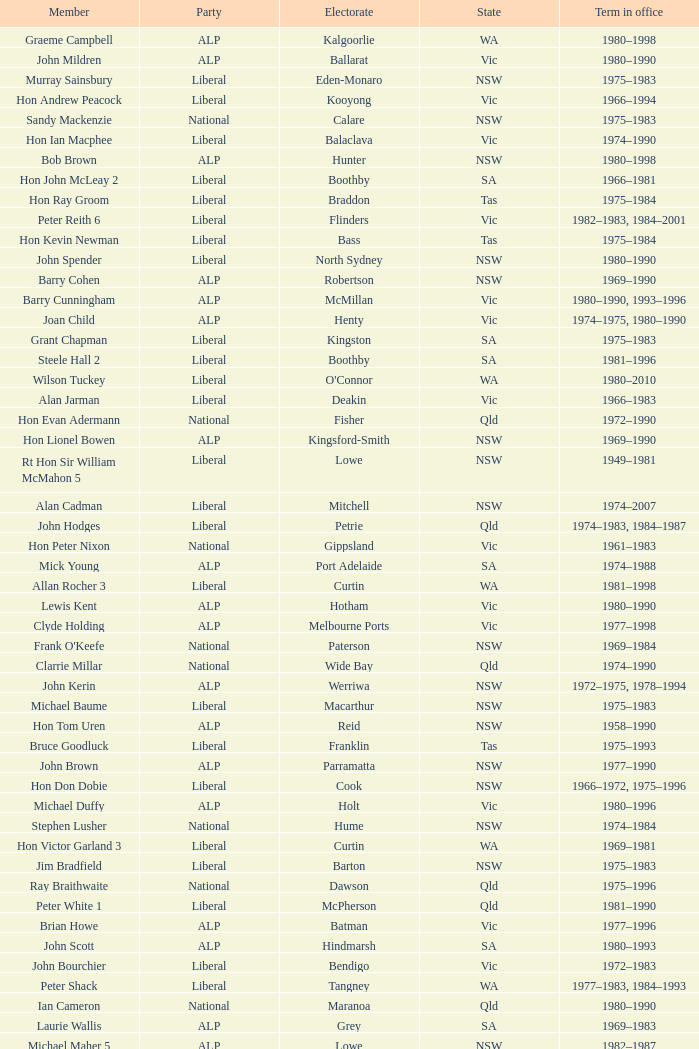Which party had a member from the state of Vic and an Electorate called Wannon? Liberal. 